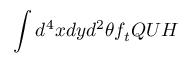<formula> <loc_0><loc_0><loc_500><loc_500>\int d ^ { 4 } x d y d ^ { 2 } \theta f _ { t } Q U H</formula> 